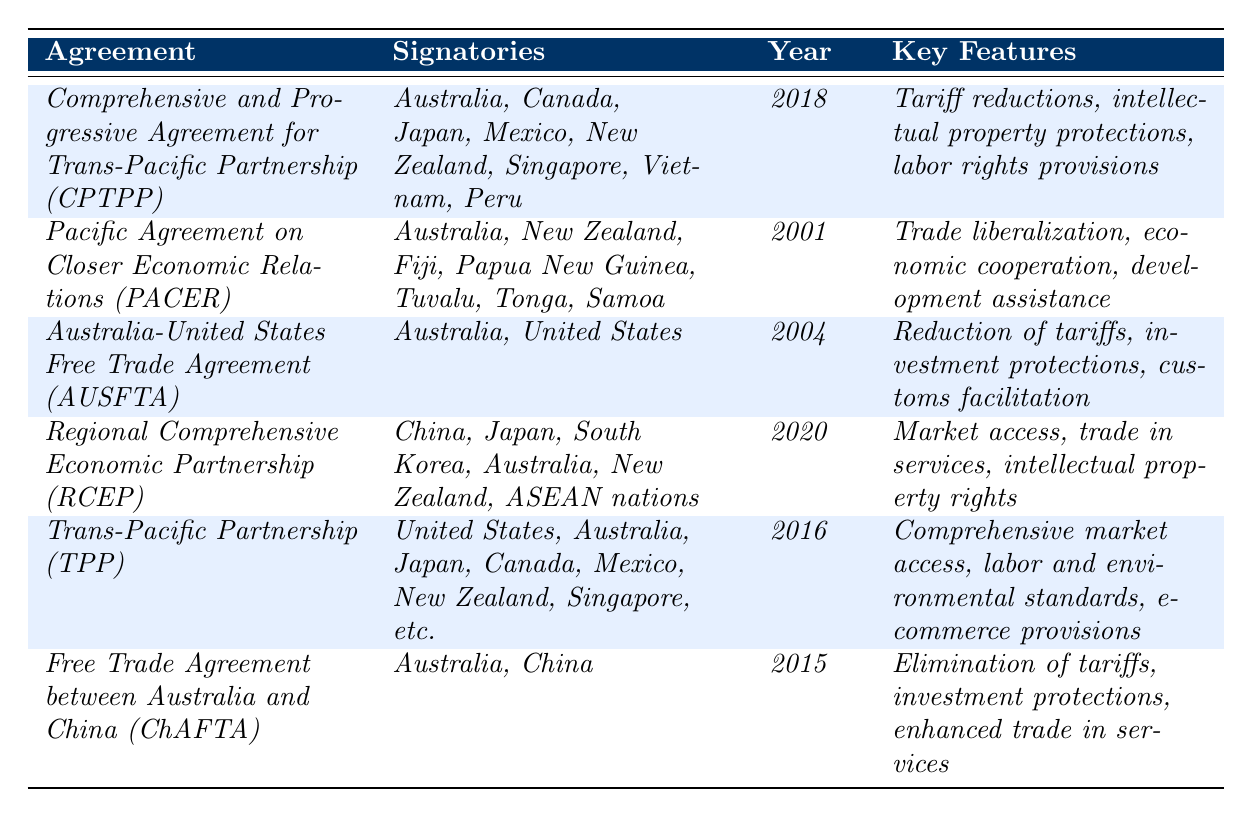What is the year the CPTPP was signed? The table states that the CPTPP was signed in the year 2018.
Answer: 2018 Which countries are signatories of the RCEP? According to the table, the signatory countries of the RCEP include China, Japan, South Korea, Australia, New Zealand, and ASEAN nations.
Answer: China, Japan, South Korea, Australia, New Zealand, ASEAN nations How many trade agreements were signed after 2015? The agreements signed after 2015 are the RCEP (2020) and CPTPP (2018), totaling two agreements.
Answer: 2 Is Australia a signatory in the TPP? The table indicates that Australia is included among the signatory countries of the TPP.
Answer: Yes What are the key features of the PACER? The table lists the key features of PACER as trade liberalization, economic cooperation, and development assistance.
Answer: Trade liberalization, economic cooperation, development assistance Which agreement has the most recent signing date? The RCEP is signed in 2020, making it the most recent agreement listed in the table.
Answer: RCEP Which agreement involves the United States and was signed in 2004? The AUSFTA, which involves the United States and Australia, was signed in 2004.
Answer: AUSFTA How many agreements listed include intellectual property protections? The CPTPP and RCEP include key features related to intellectual property protections, making a total of two agreements.
Answer: 2 Are there any agreements focused on labor rights? The CPTPP includes labor rights provisions as one of its key features, confirming that there is at least one agreement focused on labor rights.
Answer: Yes What is the common theme among the agreements signed before 2015? The agreements signed before 2015 mainly focus on trade liberalization and economic cooperation, which are recurring themes throughout.
Answer: Trade liberalization and economic cooperation Which countries are signatories of the ChAFTA? The ChAFTA is signed by Australia and China, according to the table.
Answer: Australia and China 